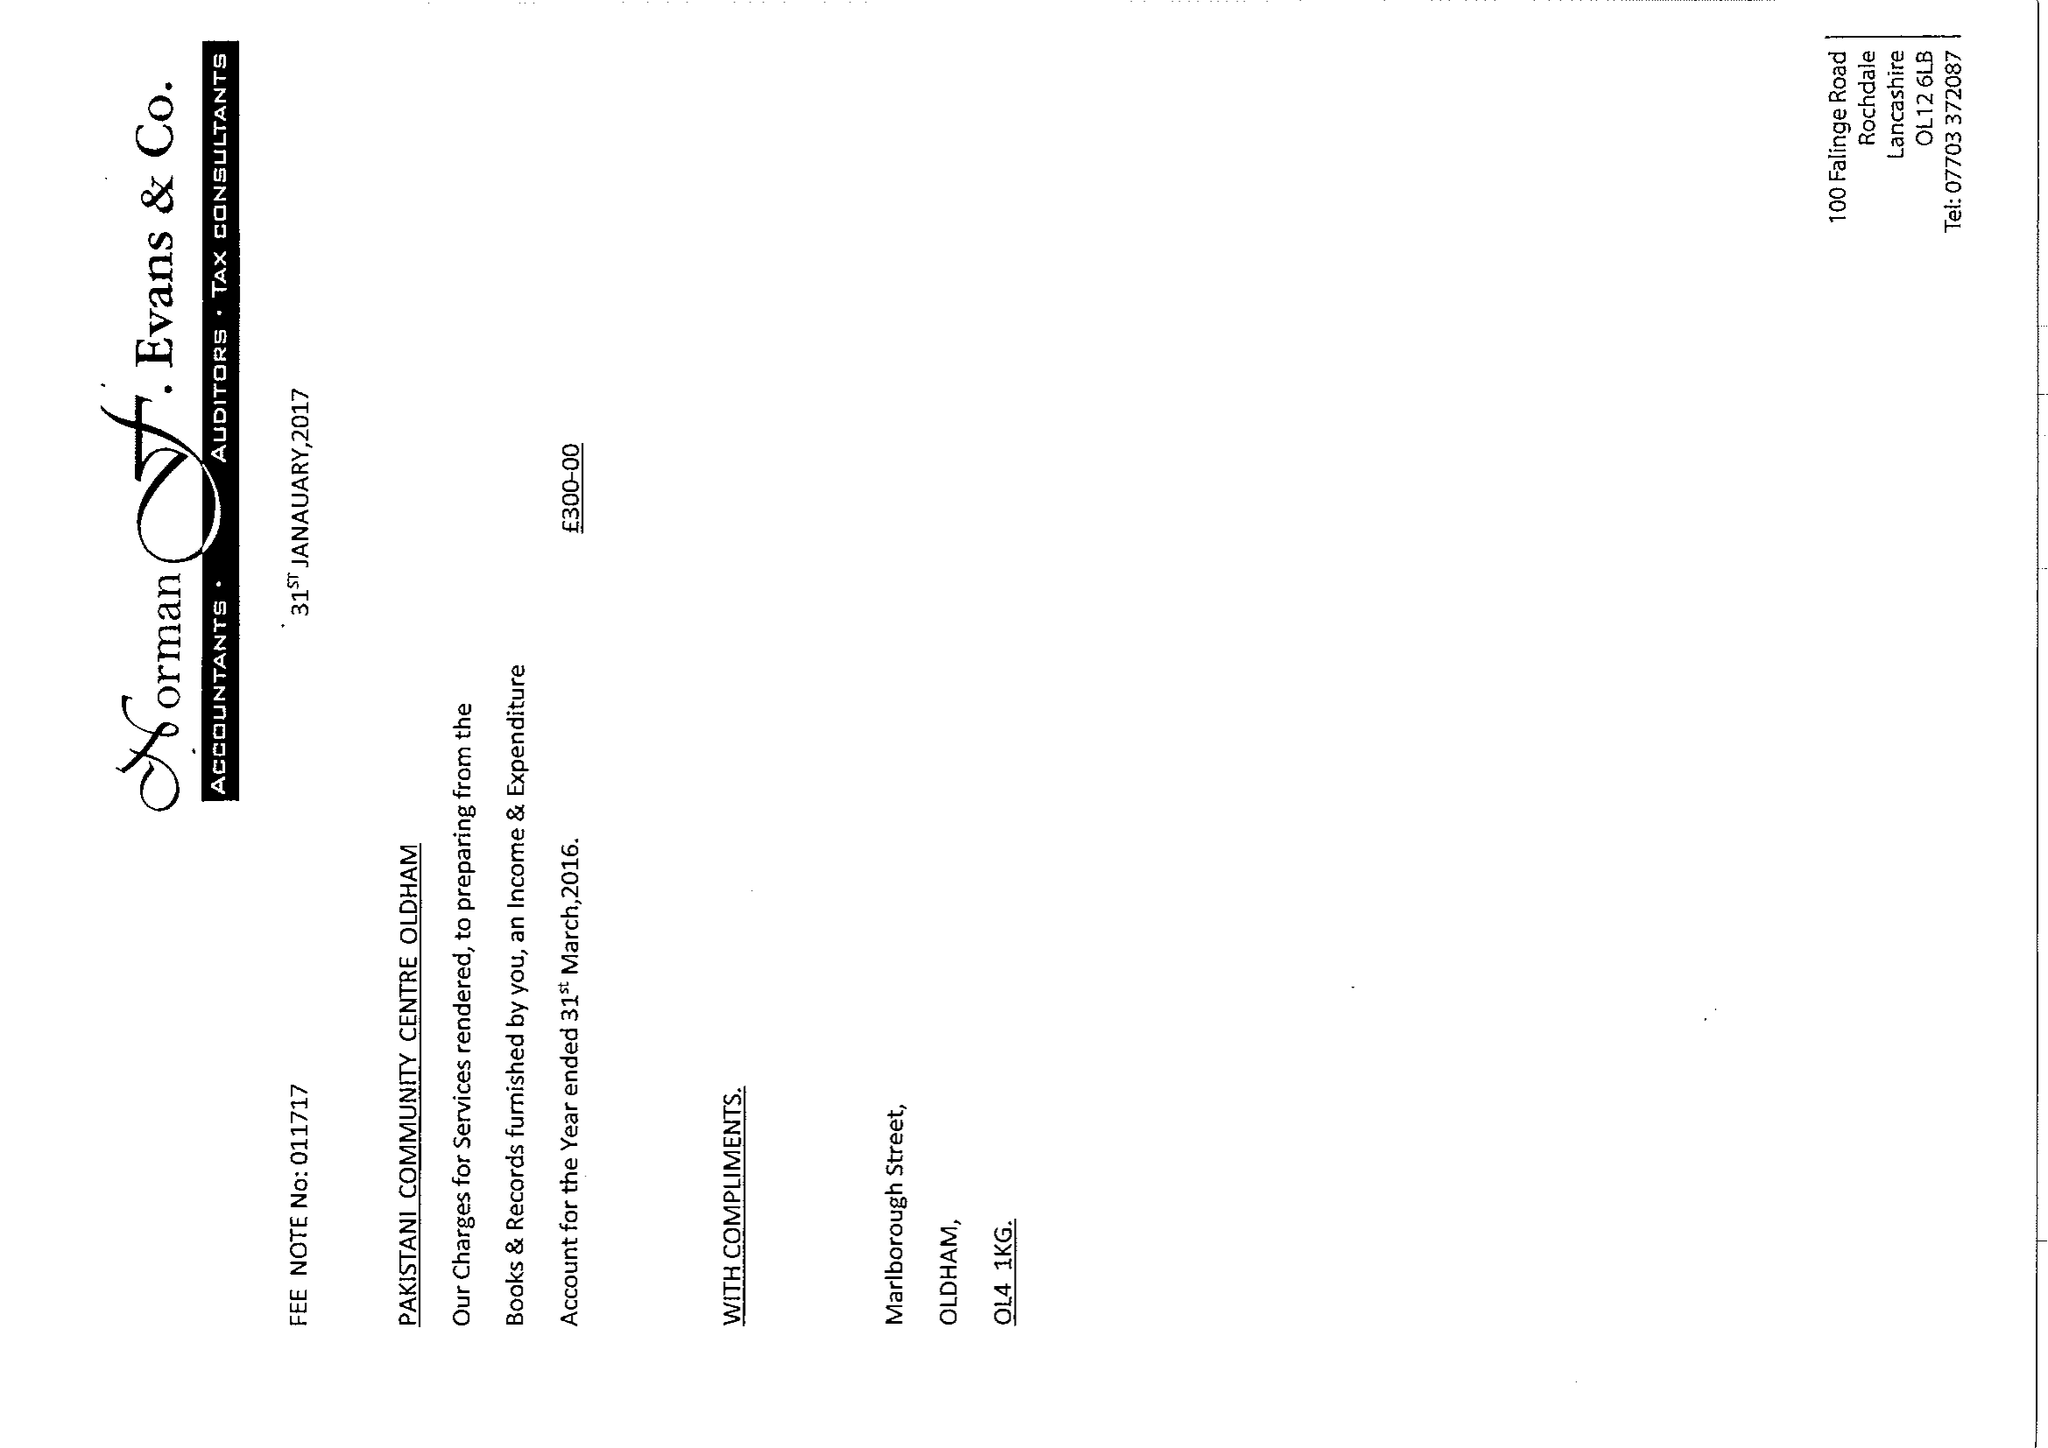What is the value for the spending_annually_in_british_pounds?
Answer the question using a single word or phrase. 68590.00 